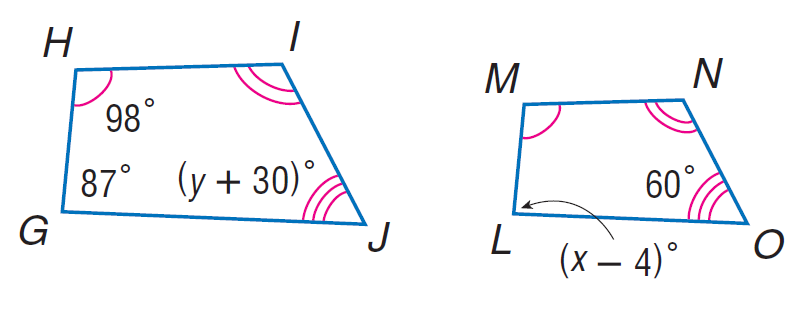Answer the mathemtical geometry problem and directly provide the correct option letter.
Question: Each pair of polygons is similar. Find x.
Choices: A: 60 B: 87 C: 91 D: 98 C 